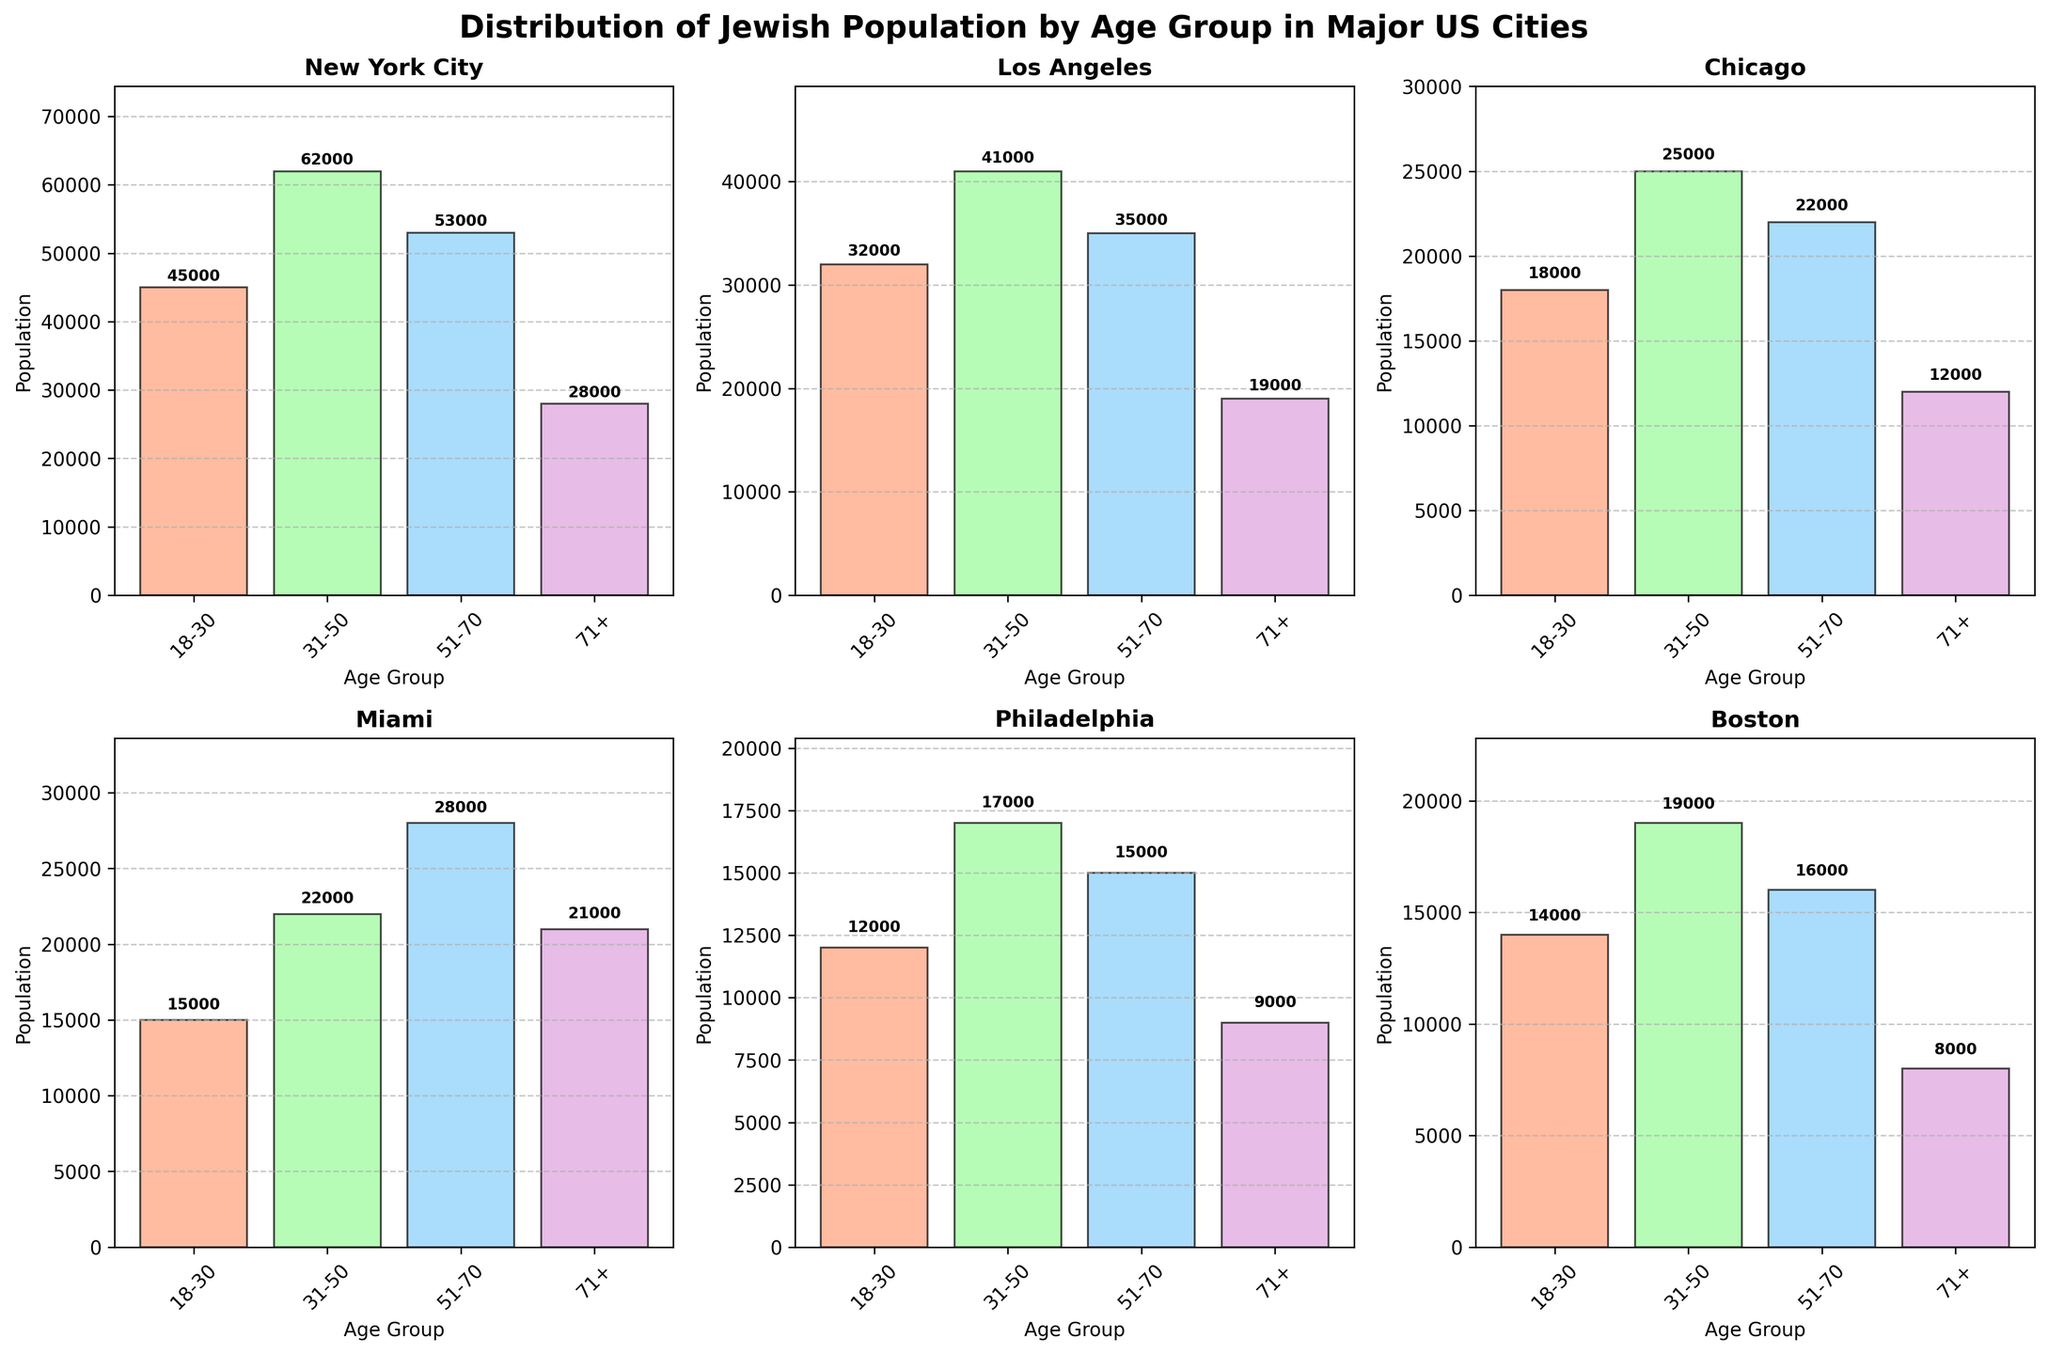Which city has the highest Jewish population in the 31-50 age group? To answer, look at the 31-50 age group bar for each city. New York City has the tallest bar in this group with 62,000 people.
Answer: New York City What is the total Jewish population for all age groups in Los Angeles? Sum the populations for Los Angeles across all age groups: 32,000 + 41,000 + 35,000 + 19,000 = 127,000
Answer: 127,000 Which city has the smallest Jewish population in the 71+ age group? Compare the 71+ age group populations for each city. Boston has the smallest population with 8,000 people.
Answer: Boston What's the difference in population between the 18-30 and 51-70 age groups in Miami? Subtract the population of the 18-30 age group from the 51-70 age group in Miami: 28,000 - 15,000 = 13,000
Answer: 13,000 Which city's age group 51-70 is almost equal to its age group 31-50 population? Look for cities where the bars for 51-70 and 31-50 age groups are nearly the same height. Miami's populations are 28,000 and 22,000 respectively, which are close in value.
Answer: Miami Between Philadelphia and Boston, which city has a higher total Jewish population in all age groups combined? Sum the population across all age groups for both cities: Philadelphia (12,000 + 17,000 + 15,000 + 9,000 = 53,000), Boston (14,000 + 19,000 + 16,000 + 8,000 = 57,000). Compare the totals.
Answer: Boston How many cities have more than 20,000 Jewish individuals in the 18-30 age group? Check the 18-30 age group bar for each city and count those with more than 20,000. New York City, Los Angeles, and Miami exceed this number.
Answer: 3 Which city's total population decreases the most from the 31-50 to the 71+ age group? For each city, subtract the 71+ age group population from the 31-50 age group population and find the city with the largest difference. New York City has a difference of 62,000 - 28,000 = 34,000.
Answer: New York City In which city is the population difference between the youngest (18-30) and the oldest (71+) age groups the largest? Subtract the 71+ age group population from the 18-30 age group population for each city. New York City has a difference of 45,000 - 28,000 = 17,000.
Answer: New York City 